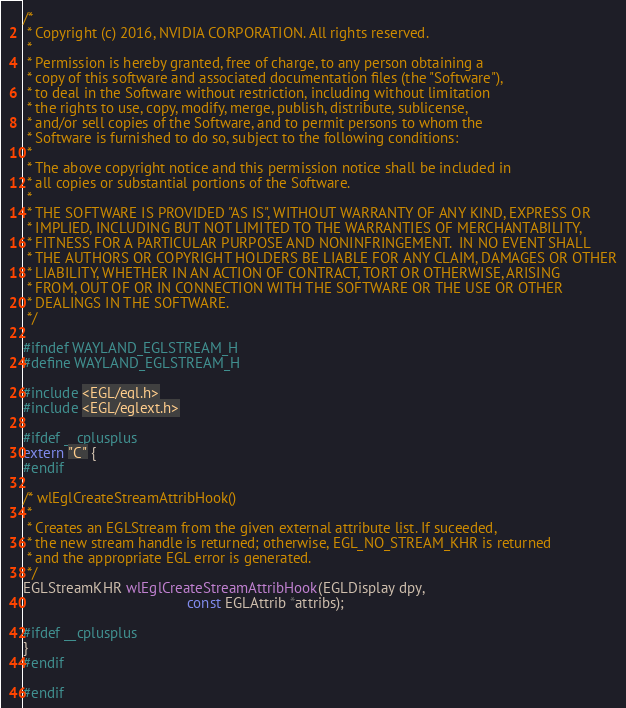Convert code to text. <code><loc_0><loc_0><loc_500><loc_500><_C_>/*
 * Copyright (c) 2016, NVIDIA CORPORATION. All rights reserved.
 *
 * Permission is hereby granted, free of charge, to any person obtaining a
 * copy of this software and associated documentation files (the "Software"),
 * to deal in the Software without restriction, including without limitation
 * the rights to use, copy, modify, merge, publish, distribute, sublicense,
 * and/or sell copies of the Software, and to permit persons to whom the
 * Software is furnished to do so, subject to the following conditions:
 *
 * The above copyright notice and this permission notice shall be included in
 * all copies or substantial portions of the Software.
 *
 * THE SOFTWARE IS PROVIDED "AS IS", WITHOUT WARRANTY OF ANY KIND, EXPRESS OR
 * IMPLIED, INCLUDING BUT NOT LIMITED TO THE WARRANTIES OF MERCHANTABILITY,
 * FITNESS FOR A PARTICULAR PURPOSE AND NONINFRINGEMENT.  IN NO EVENT SHALL
 * THE AUTHORS OR COPYRIGHT HOLDERS BE LIABLE FOR ANY CLAIM, DAMAGES OR OTHER
 * LIABILITY, WHETHER IN AN ACTION OF CONTRACT, TORT OR OTHERWISE, ARISING
 * FROM, OUT OF OR IN CONNECTION WITH THE SOFTWARE OR THE USE OR OTHER
 * DEALINGS IN THE SOFTWARE.
 */

#ifndef WAYLAND_EGLSTREAM_H
#define WAYLAND_EGLSTREAM_H

#include <EGL/egl.h>
#include <EGL/eglext.h>

#ifdef __cplusplus
extern "C" {
#endif

/* wlEglCreateStreamAttribHook()
 *
 * Creates an EGLStream from the given external attribute list. If suceeded,
 * the new stream handle is returned; otherwise, EGL_NO_STREAM_KHR is returned
 * and the appropriate EGL error is generated.
 */
EGLStreamKHR wlEglCreateStreamAttribHook(EGLDisplay dpy,
                                         const EGLAttrib *attribs);

#ifdef __cplusplus
}
#endif

#endif
</code> 